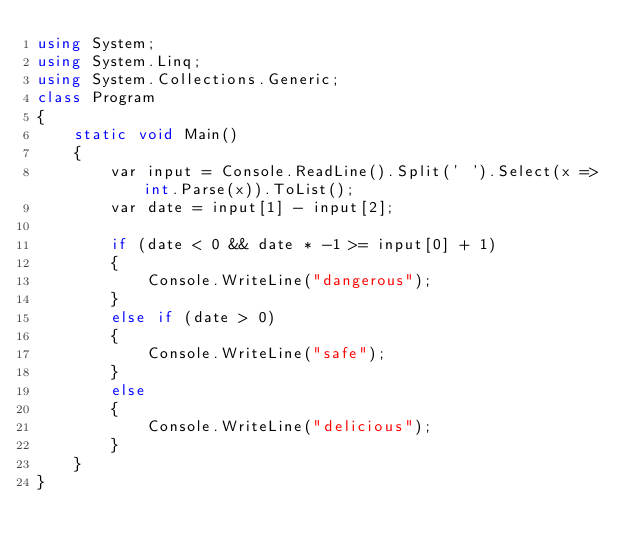Convert code to text. <code><loc_0><loc_0><loc_500><loc_500><_C#_>using System;
using System.Linq;
using System.Collections.Generic;
class Program
{
    static void Main()
    {
        var input = Console.ReadLine().Split(' ').Select(x => int.Parse(x)).ToList();
        var date = input[1] - input[2];

        if (date < 0 && date * -1 >= input[0] + 1)
        {
            Console.WriteLine("dangerous");
        }
        else if (date > 0)
        {
            Console.WriteLine("safe");
        }
        else
        {
            Console.WriteLine("delicious");
        }
    }
}</code> 